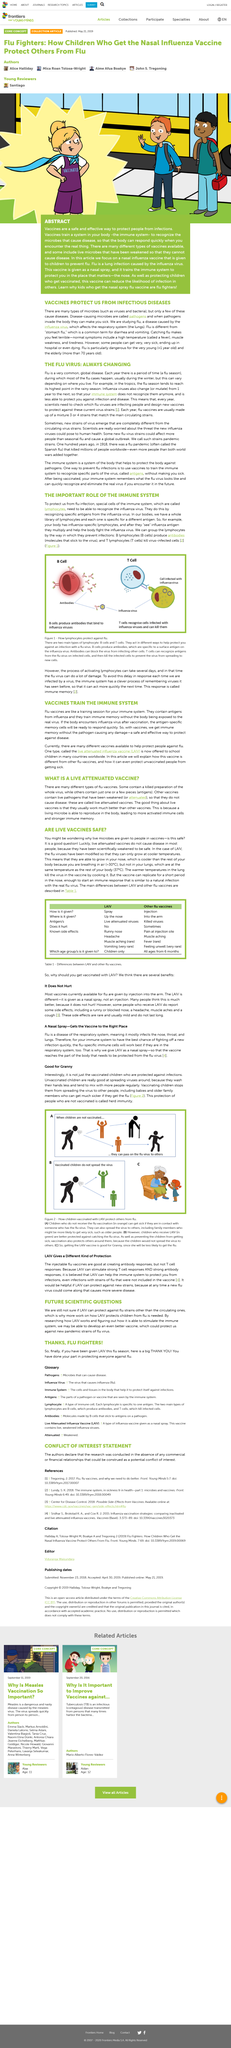Point out several critical features in this image. The vaccine replicates in the nose. The orange-clad individuals in Figure 2 (A) symbolize children who are not vaccinated against the flu. The fact that unvaccinated children can become ill if exposed to someone with the flu virus, even if they have not received the flu vaccine, is undeniable. The administration of LAIV does not hurt. The protection provided to individuals who have not been vaccinated is known as herd immunity. This is achieved when a sufficient percentage of a population has been vaccinated, thus providing a barrier of protection for those who are unable to receive vaccinations or have not been vaccinated yet. It is important to maintain herd immunity to prevent the spread of infectious diseases and protect vulnerable populations. 